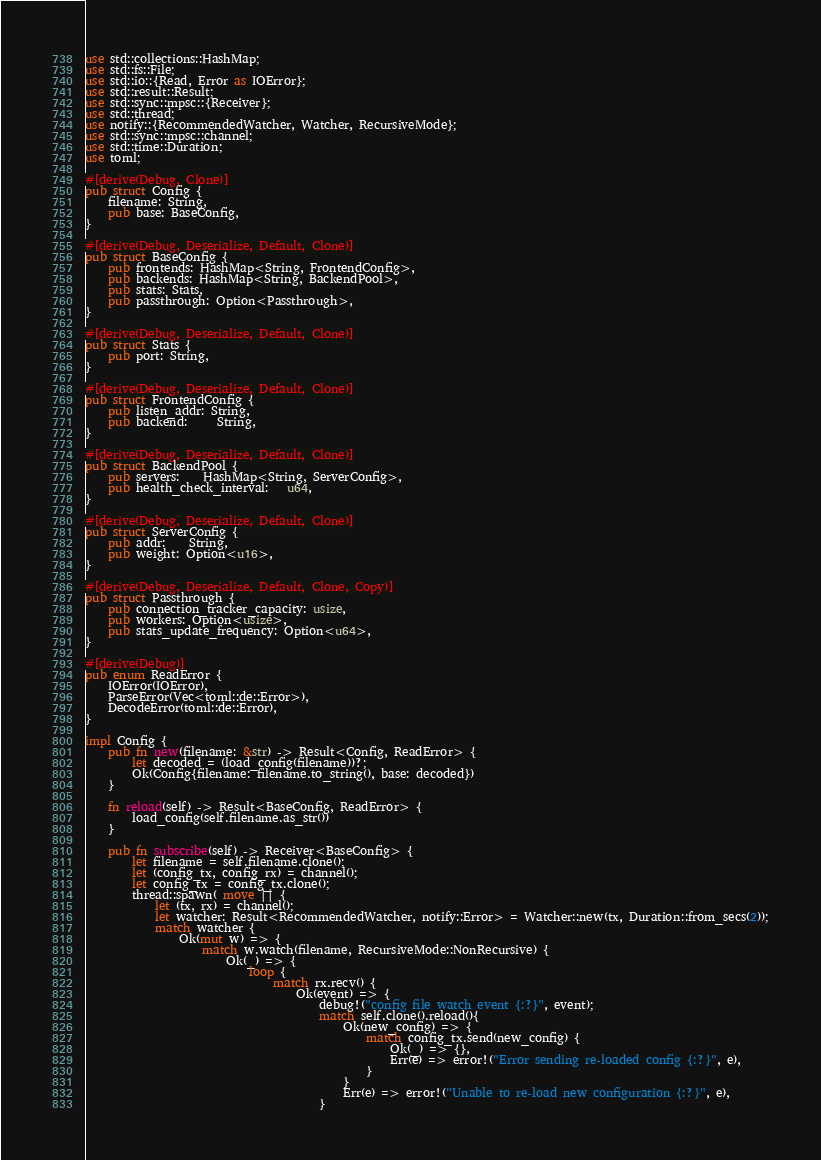Convert code to text. <code><loc_0><loc_0><loc_500><loc_500><_Rust_>use std::collections::HashMap;
use std::fs::File;
use std::io::{Read, Error as IOError};
use std::result::Result;
use std::sync::mpsc::{Receiver};
use std::thread;
use notify::{RecommendedWatcher, Watcher, RecursiveMode};
use std::sync::mpsc::channel;
use std::time::Duration;
use toml;

#[derive(Debug, Clone)]
pub struct Config {
    filename: String,
    pub base: BaseConfig,
}

#[derive(Debug, Deserialize, Default, Clone)]
pub struct BaseConfig {
    pub frontends: HashMap<String, FrontendConfig>,
    pub backends: HashMap<String, BackendPool>,
    pub stats: Stats,
    pub passthrough: Option<Passthrough>,
}

#[derive(Debug, Deserialize, Default, Clone)]
pub struct Stats {
    pub port: String,
}

#[derive(Debug, Deserialize, Default, Clone)]
pub struct FrontendConfig {
    pub listen_addr: String,
    pub backend:     String,
}

#[derive(Debug, Deserialize, Default, Clone)]
pub struct BackendPool {
    pub servers:    HashMap<String, ServerConfig>,
    pub health_check_interval:   u64,
}

#[derive(Debug, Deserialize, Default, Clone)]
pub struct ServerConfig {
    pub addr:    String,
    pub weight: Option<u16>,
}

#[derive(Debug, Deserialize, Default, Clone, Copy)]
pub struct Passthrough {
    pub connection_tracker_capacity: usize,
    pub workers: Option<usize>,
    pub stats_update_frequency: Option<u64>,
}

#[derive(Debug)]
pub enum ReadError {
    IOError(IOError),
    ParseError(Vec<toml::de::Error>),
    DecodeError(toml::de::Error),
}

impl Config {
    pub fn new(filename: &str) -> Result<Config, ReadError> {
        let decoded = (load_config(filename))?;
        Ok(Config{filename: filename.to_string(), base: decoded})
    }

    fn reload(self) -> Result<BaseConfig, ReadError> {
        load_config(self.filename.as_str())
    }

    pub fn subscribe(self) -> Receiver<BaseConfig> {
        let filename = self.filename.clone();
        let (config_tx, config_rx) = channel();
        let config_tx = config_tx.clone();
        thread::spawn( move || {
            let (tx, rx) = channel();
            let watcher: Result<RecommendedWatcher, notify::Error> = Watcher::new(tx, Duration::from_secs(2));
            match watcher {
                Ok(mut w) => {
                    match w.watch(filename, RecursiveMode::NonRecursive) {
                        Ok(_) => {
                            loop {
                                match rx.recv() {
                                    Ok(event) => {
                                        debug!("config file watch event {:?}", event);
                                        match self.clone().reload(){
                                            Ok(new_config) => {
                                                match config_tx.send(new_config) {
                                                    Ok(_) => {},
                                                    Err(e) => error!("Error sending re-loaded config {:?}", e),
                                                }
                                            }
                                            Err(e) => error!("Unable to re-load new configuration {:?}", e),
                                        }</code> 